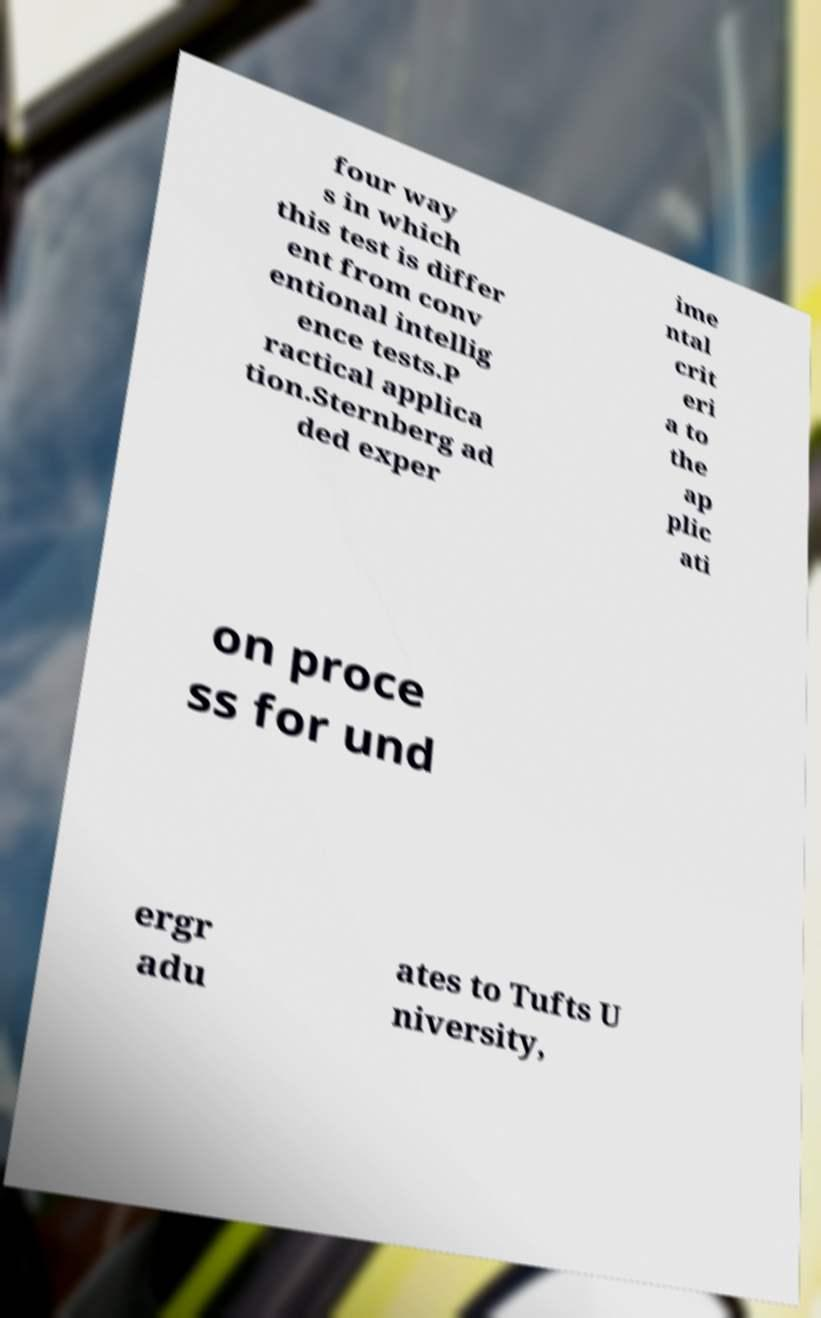Could you extract and type out the text from this image? four way s in which this test is differ ent from conv entional intellig ence tests.P ractical applica tion.Sternberg ad ded exper ime ntal crit eri a to the ap plic ati on proce ss for und ergr adu ates to Tufts U niversity, 